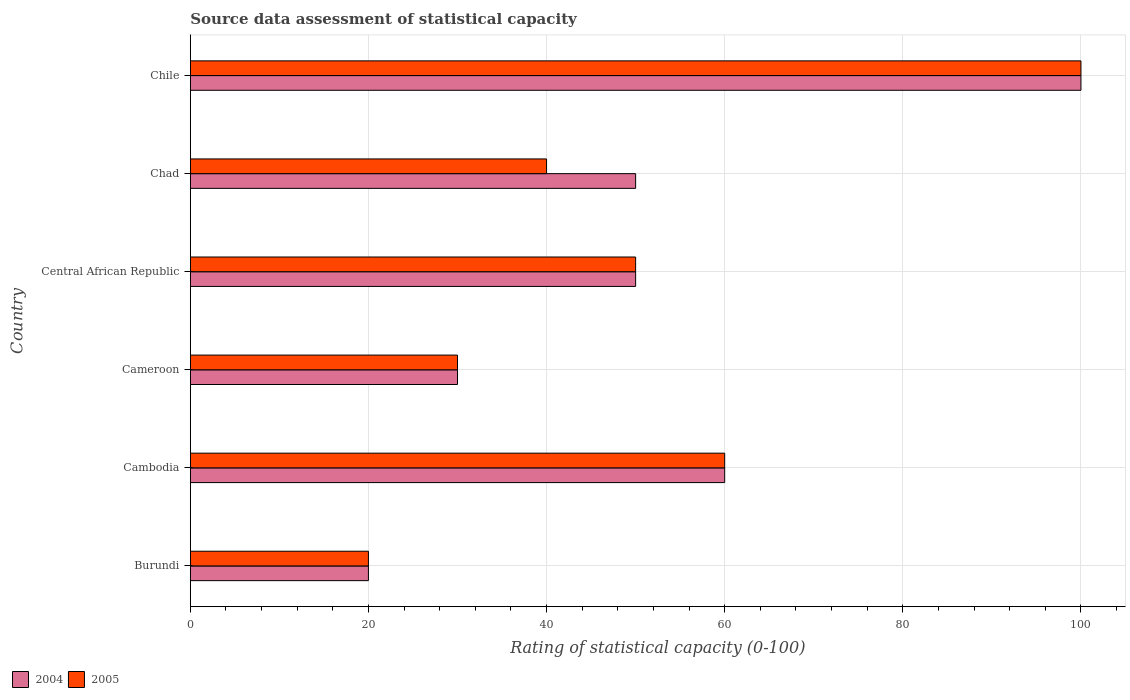How many groups of bars are there?
Keep it short and to the point. 6. How many bars are there on the 3rd tick from the bottom?
Provide a succinct answer. 2. What is the label of the 6th group of bars from the top?
Give a very brief answer. Burundi. In how many cases, is the number of bars for a given country not equal to the number of legend labels?
Make the answer very short. 0. Across all countries, what is the maximum rating of statistical capacity in 2005?
Your response must be concise. 100. In which country was the rating of statistical capacity in 2004 minimum?
Your answer should be compact. Burundi. What is the total rating of statistical capacity in 2004 in the graph?
Your answer should be very brief. 310. What is the difference between the rating of statistical capacity in 2004 in Cambodia and that in Cameroon?
Give a very brief answer. 30. What is the average rating of statistical capacity in 2004 per country?
Offer a terse response. 51.67. In how many countries, is the rating of statistical capacity in 2005 greater than 36 ?
Give a very brief answer. 4. Is the rating of statistical capacity in 2004 in Burundi less than that in Cameroon?
Give a very brief answer. Yes. Is the difference between the rating of statistical capacity in 2004 in Burundi and Chile greater than the difference between the rating of statistical capacity in 2005 in Burundi and Chile?
Provide a succinct answer. No. In how many countries, is the rating of statistical capacity in 2004 greater than the average rating of statistical capacity in 2004 taken over all countries?
Provide a succinct answer. 2. Is the sum of the rating of statistical capacity in 2004 in Cameroon and Chad greater than the maximum rating of statistical capacity in 2005 across all countries?
Offer a terse response. No. What does the 1st bar from the top in Chile represents?
Offer a terse response. 2005. How many bars are there?
Provide a succinct answer. 12. Does the graph contain any zero values?
Make the answer very short. No. How many legend labels are there?
Provide a succinct answer. 2. What is the title of the graph?
Provide a succinct answer. Source data assessment of statistical capacity. What is the label or title of the X-axis?
Give a very brief answer. Rating of statistical capacity (0-100). What is the label or title of the Y-axis?
Your answer should be very brief. Country. What is the Rating of statistical capacity (0-100) in 2004 in Burundi?
Ensure brevity in your answer.  20. What is the Rating of statistical capacity (0-100) in 2004 in Cambodia?
Your answer should be very brief. 60. What is the Rating of statistical capacity (0-100) of 2005 in Cambodia?
Your answer should be compact. 60. What is the Rating of statistical capacity (0-100) of 2004 in Cameroon?
Your answer should be compact. 30. What is the Rating of statistical capacity (0-100) in 2005 in Cameroon?
Your answer should be compact. 30. What is the Rating of statistical capacity (0-100) in 2004 in Chad?
Your response must be concise. 50. Across all countries, what is the maximum Rating of statistical capacity (0-100) in 2004?
Ensure brevity in your answer.  100. Across all countries, what is the maximum Rating of statistical capacity (0-100) in 2005?
Offer a very short reply. 100. Across all countries, what is the minimum Rating of statistical capacity (0-100) in 2004?
Your response must be concise. 20. What is the total Rating of statistical capacity (0-100) in 2004 in the graph?
Your answer should be compact. 310. What is the total Rating of statistical capacity (0-100) in 2005 in the graph?
Your response must be concise. 300. What is the difference between the Rating of statistical capacity (0-100) of 2004 in Burundi and that in Cameroon?
Provide a succinct answer. -10. What is the difference between the Rating of statistical capacity (0-100) in 2004 in Burundi and that in Central African Republic?
Your answer should be compact. -30. What is the difference between the Rating of statistical capacity (0-100) in 2005 in Burundi and that in Chad?
Give a very brief answer. -20. What is the difference between the Rating of statistical capacity (0-100) of 2004 in Burundi and that in Chile?
Your answer should be very brief. -80. What is the difference between the Rating of statistical capacity (0-100) of 2005 in Burundi and that in Chile?
Your answer should be compact. -80. What is the difference between the Rating of statistical capacity (0-100) in 2004 in Cambodia and that in Cameroon?
Give a very brief answer. 30. What is the difference between the Rating of statistical capacity (0-100) of 2005 in Cambodia and that in Cameroon?
Your answer should be very brief. 30. What is the difference between the Rating of statistical capacity (0-100) in 2005 in Cambodia and that in Central African Republic?
Offer a very short reply. 10. What is the difference between the Rating of statistical capacity (0-100) of 2004 in Cambodia and that in Chad?
Make the answer very short. 10. What is the difference between the Rating of statistical capacity (0-100) in 2005 in Cambodia and that in Chad?
Provide a succinct answer. 20. What is the difference between the Rating of statistical capacity (0-100) in 2004 in Cambodia and that in Chile?
Your answer should be very brief. -40. What is the difference between the Rating of statistical capacity (0-100) of 2004 in Cameroon and that in Central African Republic?
Your answer should be compact. -20. What is the difference between the Rating of statistical capacity (0-100) in 2004 in Cameroon and that in Chile?
Your answer should be very brief. -70. What is the difference between the Rating of statistical capacity (0-100) of 2005 in Cameroon and that in Chile?
Provide a succinct answer. -70. What is the difference between the Rating of statistical capacity (0-100) in 2005 in Central African Republic and that in Chad?
Offer a very short reply. 10. What is the difference between the Rating of statistical capacity (0-100) of 2004 in Central African Republic and that in Chile?
Your answer should be very brief. -50. What is the difference between the Rating of statistical capacity (0-100) of 2005 in Central African Republic and that in Chile?
Give a very brief answer. -50. What is the difference between the Rating of statistical capacity (0-100) of 2004 in Chad and that in Chile?
Ensure brevity in your answer.  -50. What is the difference between the Rating of statistical capacity (0-100) of 2005 in Chad and that in Chile?
Your response must be concise. -60. What is the difference between the Rating of statistical capacity (0-100) of 2004 in Burundi and the Rating of statistical capacity (0-100) of 2005 in Cambodia?
Offer a terse response. -40. What is the difference between the Rating of statistical capacity (0-100) in 2004 in Burundi and the Rating of statistical capacity (0-100) in 2005 in Central African Republic?
Offer a terse response. -30. What is the difference between the Rating of statistical capacity (0-100) in 2004 in Burundi and the Rating of statistical capacity (0-100) in 2005 in Chad?
Your answer should be very brief. -20. What is the difference between the Rating of statistical capacity (0-100) in 2004 in Burundi and the Rating of statistical capacity (0-100) in 2005 in Chile?
Keep it short and to the point. -80. What is the difference between the Rating of statistical capacity (0-100) in 2004 in Cambodia and the Rating of statistical capacity (0-100) in 2005 in Central African Republic?
Ensure brevity in your answer.  10. What is the difference between the Rating of statistical capacity (0-100) of 2004 in Cambodia and the Rating of statistical capacity (0-100) of 2005 in Chile?
Give a very brief answer. -40. What is the difference between the Rating of statistical capacity (0-100) of 2004 in Cameroon and the Rating of statistical capacity (0-100) of 2005 in Central African Republic?
Your response must be concise. -20. What is the difference between the Rating of statistical capacity (0-100) in 2004 in Cameroon and the Rating of statistical capacity (0-100) in 2005 in Chad?
Keep it short and to the point. -10. What is the difference between the Rating of statistical capacity (0-100) in 2004 in Cameroon and the Rating of statistical capacity (0-100) in 2005 in Chile?
Offer a very short reply. -70. What is the difference between the Rating of statistical capacity (0-100) of 2004 in Chad and the Rating of statistical capacity (0-100) of 2005 in Chile?
Offer a very short reply. -50. What is the average Rating of statistical capacity (0-100) of 2004 per country?
Keep it short and to the point. 51.67. What is the difference between the Rating of statistical capacity (0-100) in 2004 and Rating of statistical capacity (0-100) in 2005 in Central African Republic?
Keep it short and to the point. 0. What is the difference between the Rating of statistical capacity (0-100) of 2004 and Rating of statistical capacity (0-100) of 2005 in Chad?
Offer a very short reply. 10. What is the ratio of the Rating of statistical capacity (0-100) in 2005 in Burundi to that in Cambodia?
Ensure brevity in your answer.  0.33. What is the ratio of the Rating of statistical capacity (0-100) of 2004 in Burundi to that in Central African Republic?
Your answer should be compact. 0.4. What is the ratio of the Rating of statistical capacity (0-100) of 2004 in Burundi to that in Chad?
Ensure brevity in your answer.  0.4. What is the ratio of the Rating of statistical capacity (0-100) of 2004 in Burundi to that in Chile?
Keep it short and to the point. 0.2. What is the ratio of the Rating of statistical capacity (0-100) of 2005 in Burundi to that in Chile?
Your answer should be compact. 0.2. What is the ratio of the Rating of statistical capacity (0-100) of 2005 in Cambodia to that in Central African Republic?
Your answer should be compact. 1.2. What is the ratio of the Rating of statistical capacity (0-100) of 2005 in Cambodia to that in Chad?
Offer a very short reply. 1.5. What is the ratio of the Rating of statistical capacity (0-100) of 2004 in Cambodia to that in Chile?
Your answer should be very brief. 0.6. What is the ratio of the Rating of statistical capacity (0-100) of 2004 in Cameroon to that in Central African Republic?
Offer a very short reply. 0.6. What is the ratio of the Rating of statistical capacity (0-100) of 2005 in Cameroon to that in Central African Republic?
Your answer should be compact. 0.6. What is the ratio of the Rating of statistical capacity (0-100) of 2005 in Cameroon to that in Chad?
Your response must be concise. 0.75. What is the ratio of the Rating of statistical capacity (0-100) of 2005 in Central African Republic to that in Chad?
Provide a succinct answer. 1.25. What is the ratio of the Rating of statistical capacity (0-100) in 2005 in Central African Republic to that in Chile?
Make the answer very short. 0.5. What is the ratio of the Rating of statistical capacity (0-100) in 2004 in Chad to that in Chile?
Ensure brevity in your answer.  0.5. What is the ratio of the Rating of statistical capacity (0-100) in 2005 in Chad to that in Chile?
Your answer should be compact. 0.4. What is the difference between the highest and the second highest Rating of statistical capacity (0-100) in 2005?
Your response must be concise. 40. What is the difference between the highest and the lowest Rating of statistical capacity (0-100) in 2005?
Provide a succinct answer. 80. 